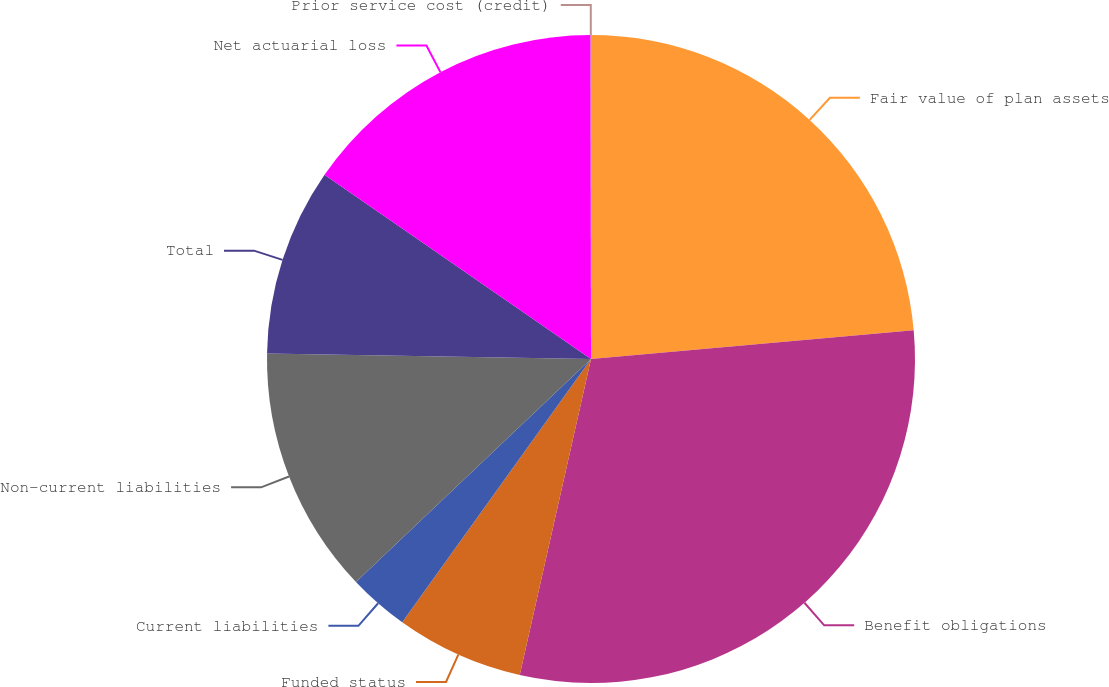Convert chart to OTSL. <chart><loc_0><loc_0><loc_500><loc_500><pie_chart><fcel>Fair value of plan assets<fcel>Benefit obligations<fcel>Funded status<fcel>Current liabilities<fcel>Non-current liabilities<fcel>Total<fcel>Net actuarial loss<fcel>Prior service cost (credit)<nl><fcel>23.58%<fcel>29.95%<fcel>6.37%<fcel>3.02%<fcel>12.35%<fcel>9.36%<fcel>15.35%<fcel>0.02%<nl></chart> 